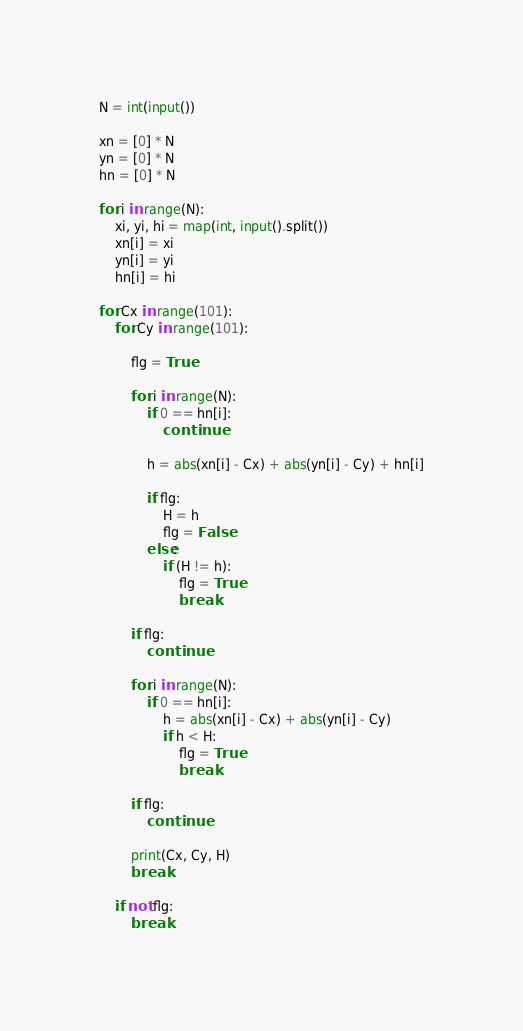<code> <loc_0><loc_0><loc_500><loc_500><_Python_>N = int(input())

xn = [0] * N
yn = [0] * N
hn = [0] * N

for i in range(N):
    xi, yi, hi = map(int, input().split())
    xn[i] = xi
    yn[i] = yi
    hn[i] = hi

for Cx in range(101):
    for Cy in range(101):

        flg = True

        for i in range(N):
            if 0 == hn[i]:
                continue

            h = abs(xn[i] - Cx) + abs(yn[i] - Cy) + hn[i]

            if flg:
                H = h
                flg = False
            else:
                if (H != h):
                    flg = True
                    break

        if flg:
            continue

        for i in range(N):
            if 0 == hn[i]:
                h = abs(xn[i] - Cx) + abs(yn[i] - Cy)
                if h < H:
                    flg = True
                    break

        if flg:
            continue

        print(Cx, Cy, H)
        break

    if not flg:
        break
</code> 